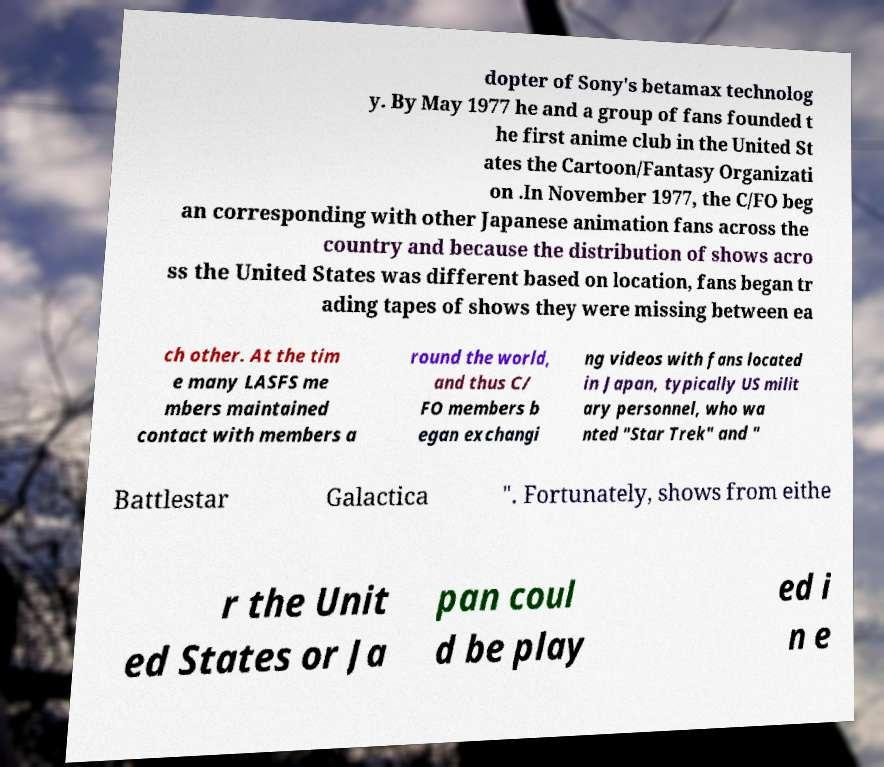There's text embedded in this image that I need extracted. Can you transcribe it verbatim? dopter of Sony's betamax technolog y. By May 1977 he and a group of fans founded t he first anime club in the United St ates the Cartoon/Fantasy Organizati on .In November 1977, the C/FO beg an corresponding with other Japanese animation fans across the country and because the distribution of shows acro ss the United States was different based on location, fans began tr ading tapes of shows they were missing between ea ch other. At the tim e many LASFS me mbers maintained contact with members a round the world, and thus C/ FO members b egan exchangi ng videos with fans located in Japan, typically US milit ary personnel, who wa nted "Star Trek" and " Battlestar Galactica ". Fortunately, shows from eithe r the Unit ed States or Ja pan coul d be play ed i n e 